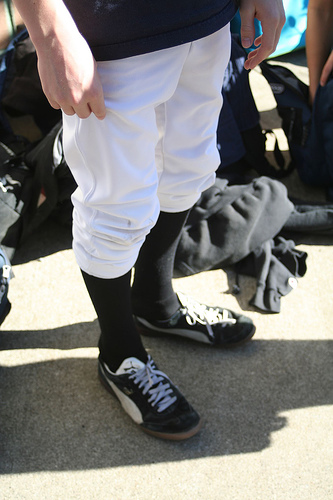<image>
Can you confirm if the man is on the shoe? Yes. Looking at the image, I can see the man is positioned on top of the shoe, with the shoe providing support. Is the shirt behind the man? No. The shirt is not behind the man. From this viewpoint, the shirt appears to be positioned elsewhere in the scene. 